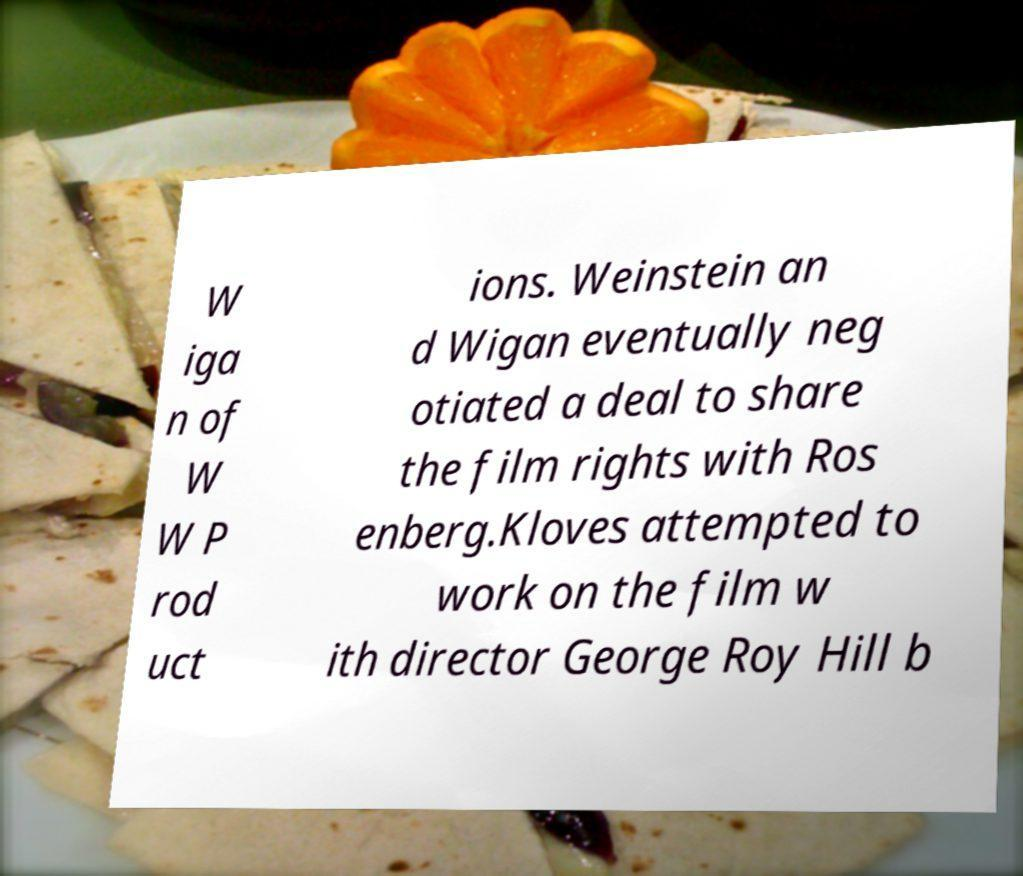I need the written content from this picture converted into text. Can you do that? W iga n of W W P rod uct ions. Weinstein an d Wigan eventually neg otiated a deal to share the film rights with Ros enberg.Kloves attempted to work on the film w ith director George Roy Hill b 